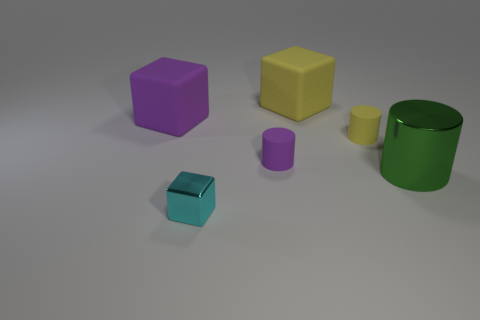Add 2 large gray metal spheres. How many objects exist? 8 Subtract 0 brown balls. How many objects are left? 6 Subtract all large cubes. Subtract all small green metal cylinders. How many objects are left? 4 Add 4 tiny cyan cubes. How many tiny cyan cubes are left? 5 Add 1 metal cylinders. How many metal cylinders exist? 2 